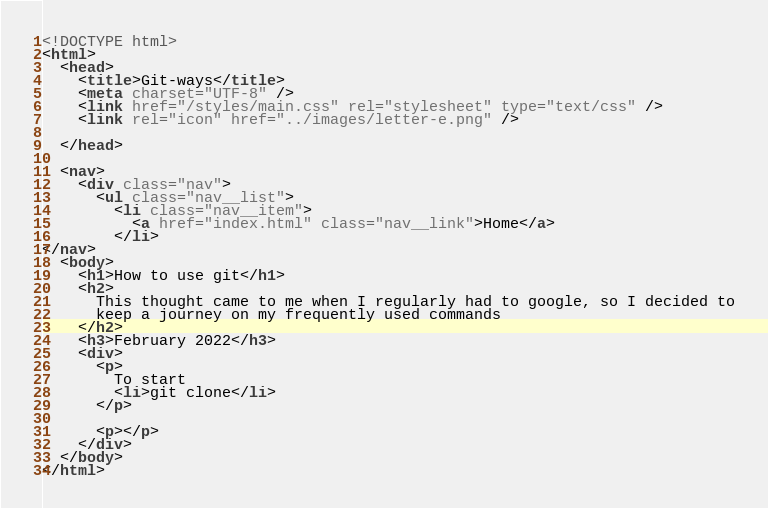Convert code to text. <code><loc_0><loc_0><loc_500><loc_500><_HTML_><!DOCTYPE html>
<html>
  <head>
    <title>Git-ways</title>
    <meta charset="UTF-8" />
    <link href="/styles/main.css" rel="stylesheet" type="text/css" />
    <link rel="icon" href="../images/letter-e.png" />

  </head>

  <nav>
    <div class="nav">
      <ul class="nav__list">
        <li class="nav__item">
          <a href="index.html" class="nav__link">Home</a>
        </li>
</nav>
  <body>
    <h1>How to use git</h1>
    <h2>
      This thought came to me when I regularly had to google, so I decided to
      keep a journey on my frequently used commands
    </h2>
    <h3>February 2022</h3>
    <div>
      <p>
        To start
        <li>git clone</li>
      </p>

      <p></p>
    </div>
  </body>
</html>
</code> 